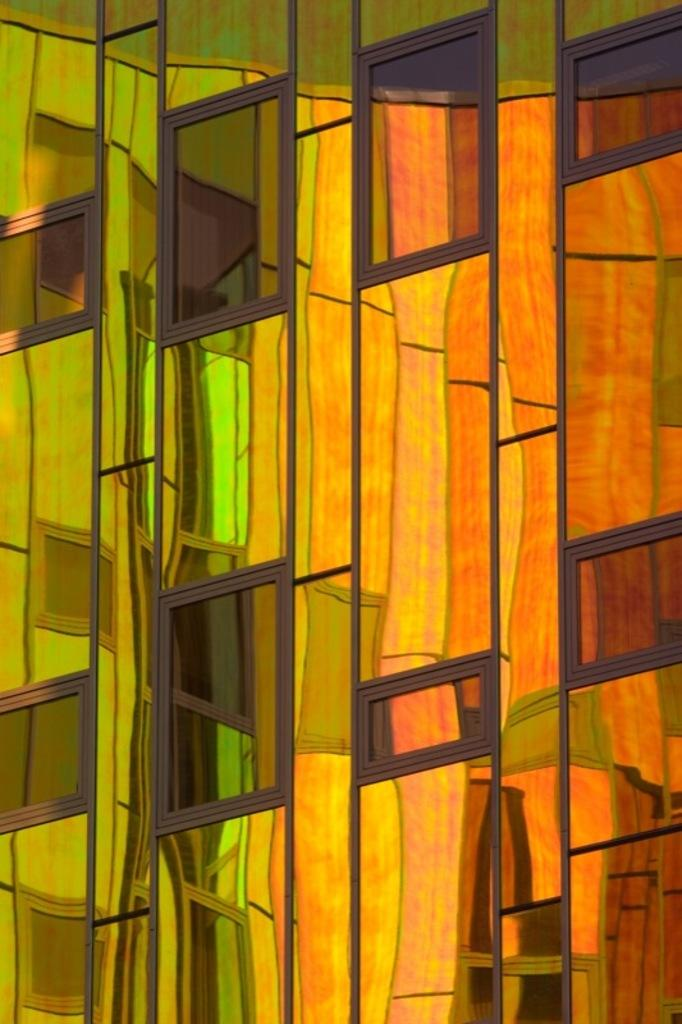What type of artwork is featured in the image? There is a stained glass in the image. What type of books can be seen on the floor near the stained glass? There is no mention of books or a floor in the image, as it only features a stained glass. How many potatoes are visible in the image? There are no potatoes present in the image; it only features a stained glass. 